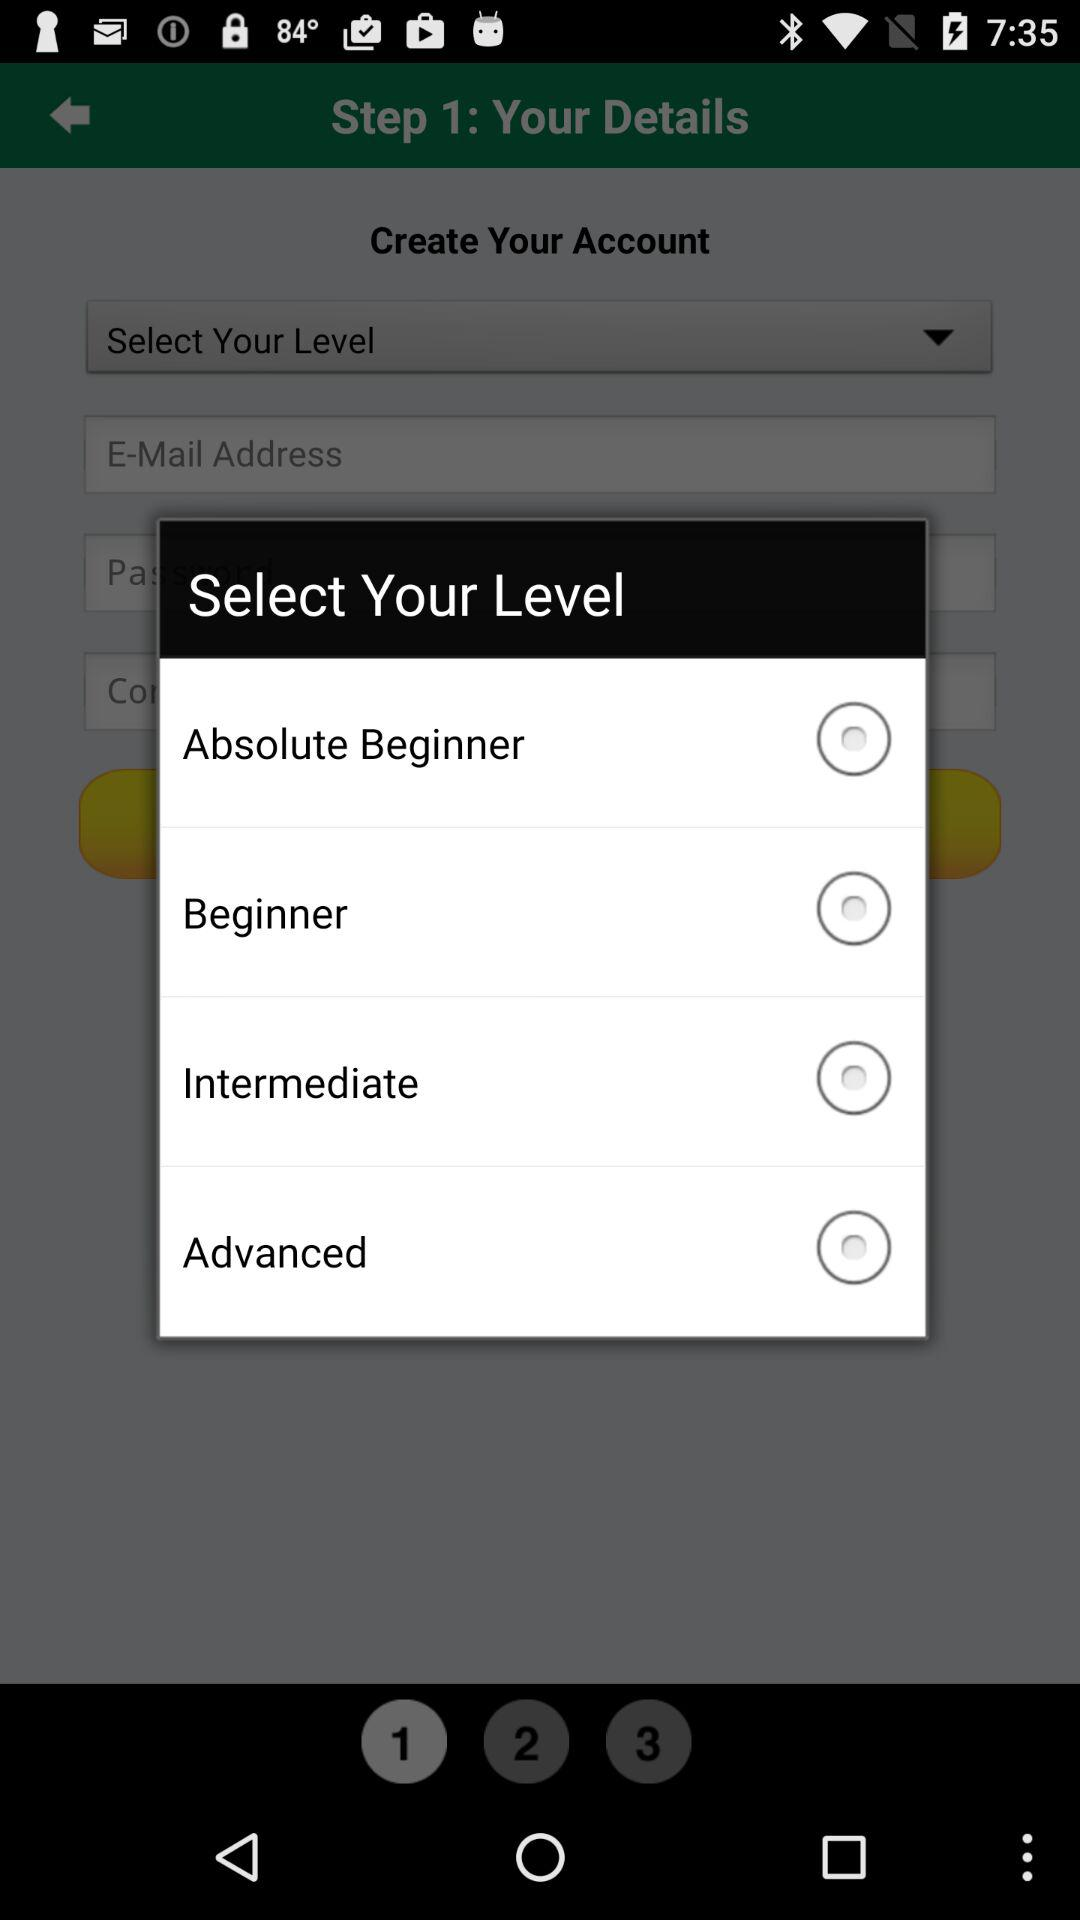How many levels are there in total?
Answer the question using a single word or phrase. 4 